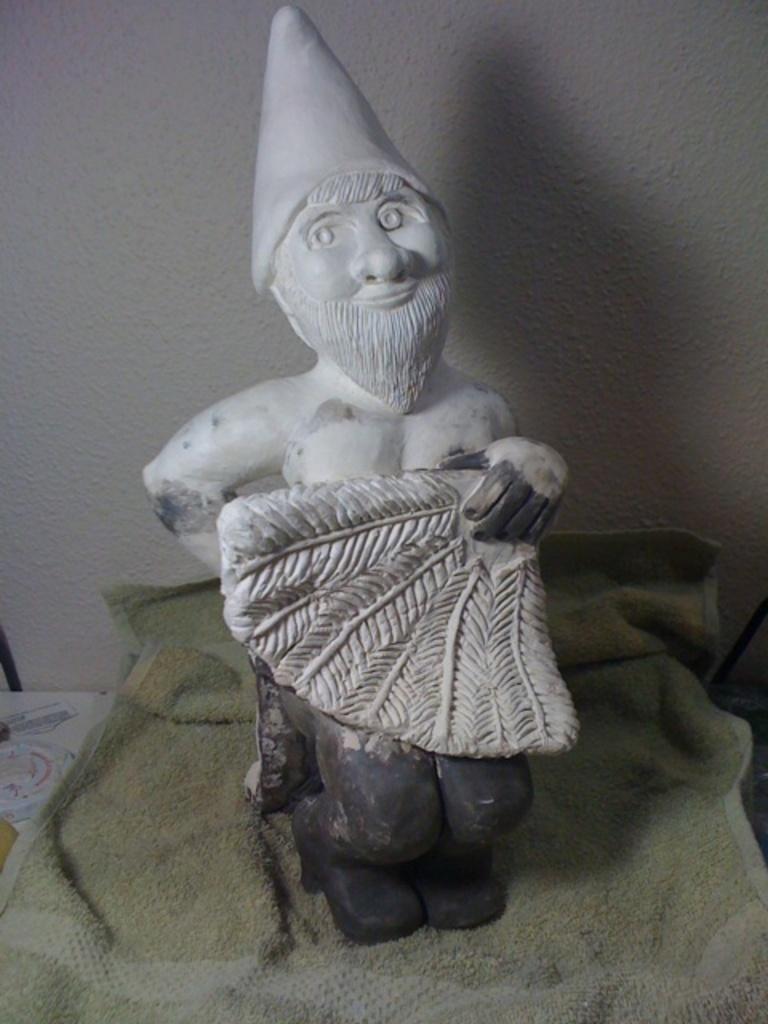Could you give a brief overview of what you see in this image? This image is taken indoors. In the background there is a wall. At the bottom of the image there is a table with a napkin and a clay doll on it. 